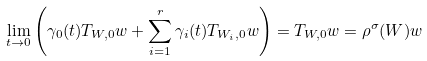Convert formula to latex. <formula><loc_0><loc_0><loc_500><loc_500>\lim _ { t \to 0 } \left ( \gamma _ { 0 } ( t ) T _ { W , 0 } w + \sum _ { i = 1 } ^ { r } \gamma _ { i } ( t ) T _ { W _ { i } , 0 } w \right ) = T _ { W , 0 } w = \rho ^ { \sigma } ( W ) w</formula> 